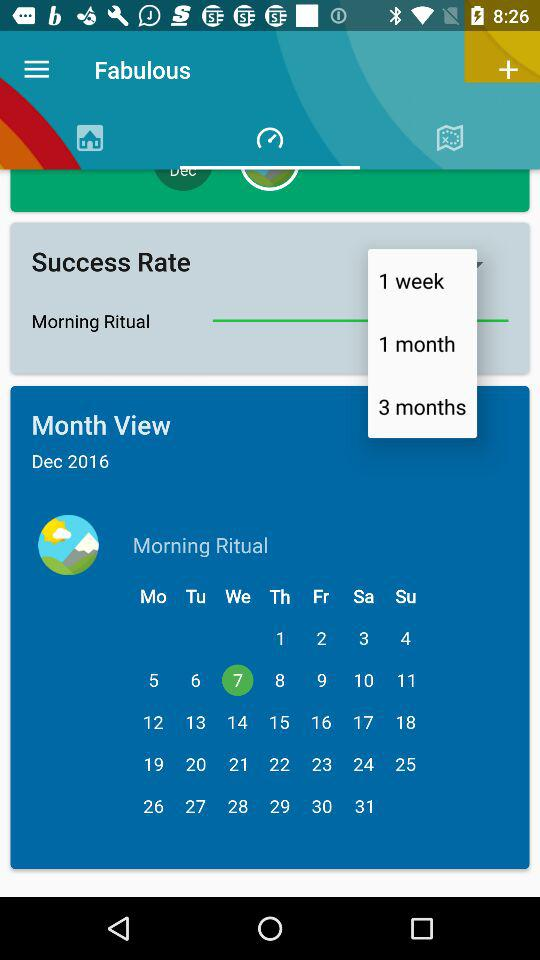Which date is selected for the morning ritual? The selected date is Wednesday, December 7, 2016. 